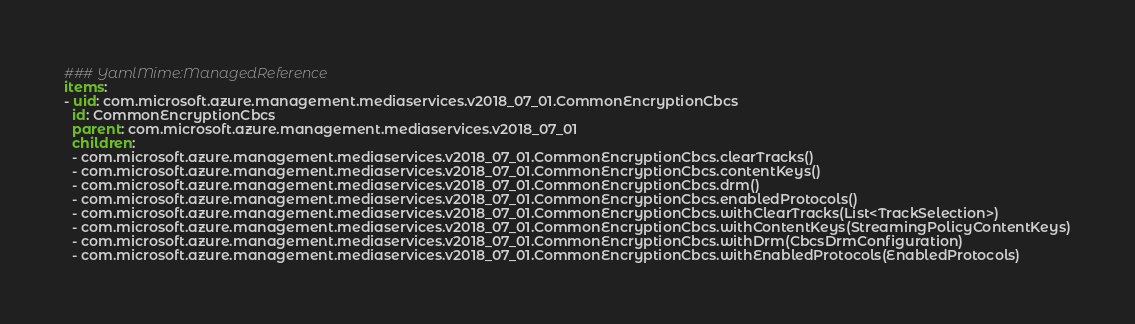<code> <loc_0><loc_0><loc_500><loc_500><_YAML_>### YamlMime:ManagedReference
items:
- uid: com.microsoft.azure.management.mediaservices.v2018_07_01.CommonEncryptionCbcs
  id: CommonEncryptionCbcs
  parent: com.microsoft.azure.management.mediaservices.v2018_07_01
  children:
  - com.microsoft.azure.management.mediaservices.v2018_07_01.CommonEncryptionCbcs.clearTracks()
  - com.microsoft.azure.management.mediaservices.v2018_07_01.CommonEncryptionCbcs.contentKeys()
  - com.microsoft.azure.management.mediaservices.v2018_07_01.CommonEncryptionCbcs.drm()
  - com.microsoft.azure.management.mediaservices.v2018_07_01.CommonEncryptionCbcs.enabledProtocols()
  - com.microsoft.azure.management.mediaservices.v2018_07_01.CommonEncryptionCbcs.withClearTracks(List<TrackSelection>)
  - com.microsoft.azure.management.mediaservices.v2018_07_01.CommonEncryptionCbcs.withContentKeys(StreamingPolicyContentKeys)
  - com.microsoft.azure.management.mediaservices.v2018_07_01.CommonEncryptionCbcs.withDrm(CbcsDrmConfiguration)
  - com.microsoft.azure.management.mediaservices.v2018_07_01.CommonEncryptionCbcs.withEnabledProtocols(EnabledProtocols)</code> 